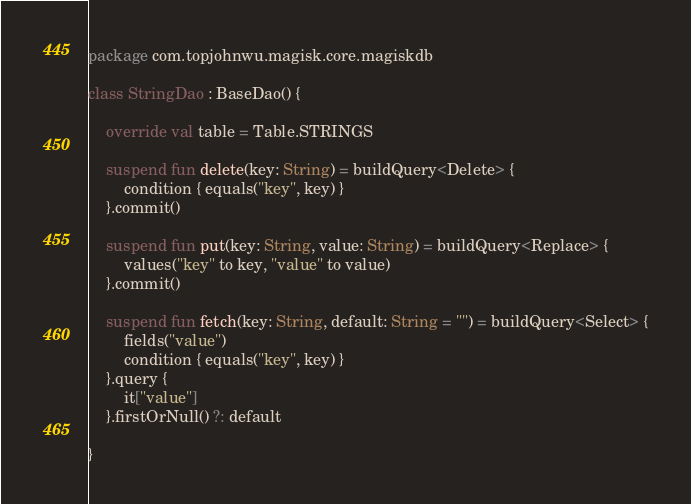Convert code to text. <code><loc_0><loc_0><loc_500><loc_500><_Kotlin_>package com.topjohnwu.magisk.core.magiskdb

class StringDao : BaseDao() {

    override val table = Table.STRINGS

    suspend fun delete(key: String) = buildQuery<Delete> {
        condition { equals("key", key) }
    }.commit()

    suspend fun put(key: String, value: String) = buildQuery<Replace> {
        values("key" to key, "value" to value)
    }.commit()

    suspend fun fetch(key: String, default: String = "") = buildQuery<Select> {
        fields("value")
        condition { equals("key", key) }
    }.query {
        it["value"]
    }.firstOrNull() ?: default

}
</code> 